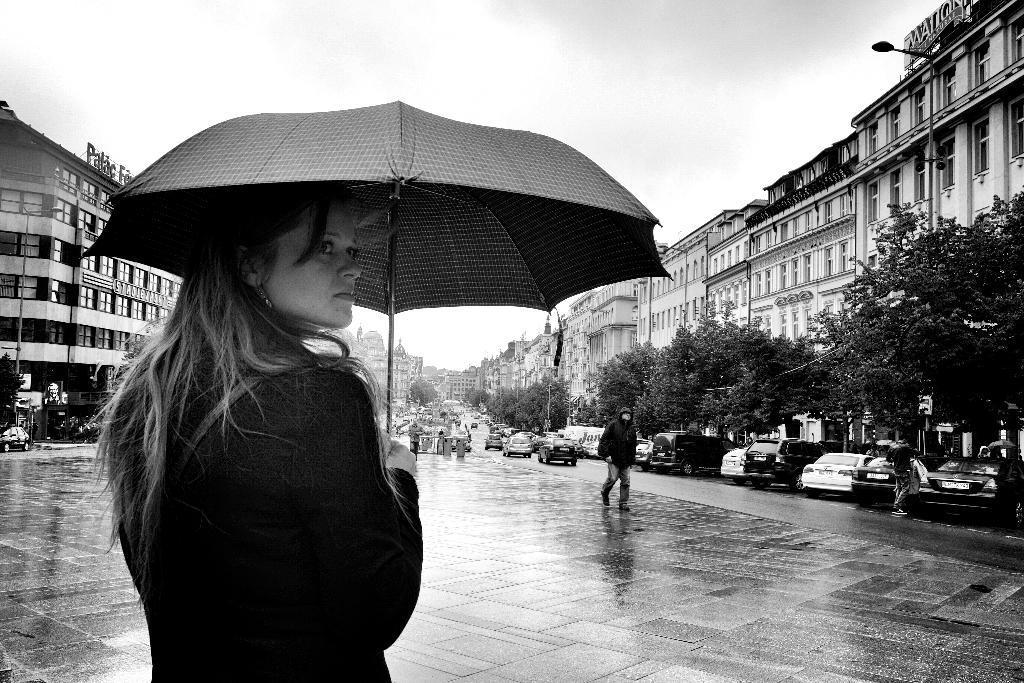Describe this image in one or two sentences. This is a black and white image. On the left side of the image we can see a lady is standing and holding an umbrella. In the background of the image we can see the buildings, windows, trees, vehicles, road, boards, light and some people. In the center of the image we can see a man is walking. At the bottom of the image we can see the road. At the top of the image we can see the sky. 